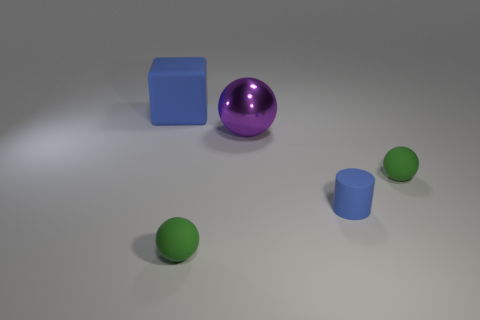Can you describe the position and texture of the smallest object in the image? Certainly! The smallest object in the image is a matte-finished green sphere. It is positioned on the far right side of the image, in front of the larger green sphere and to the left of the cylindrical blue object. 